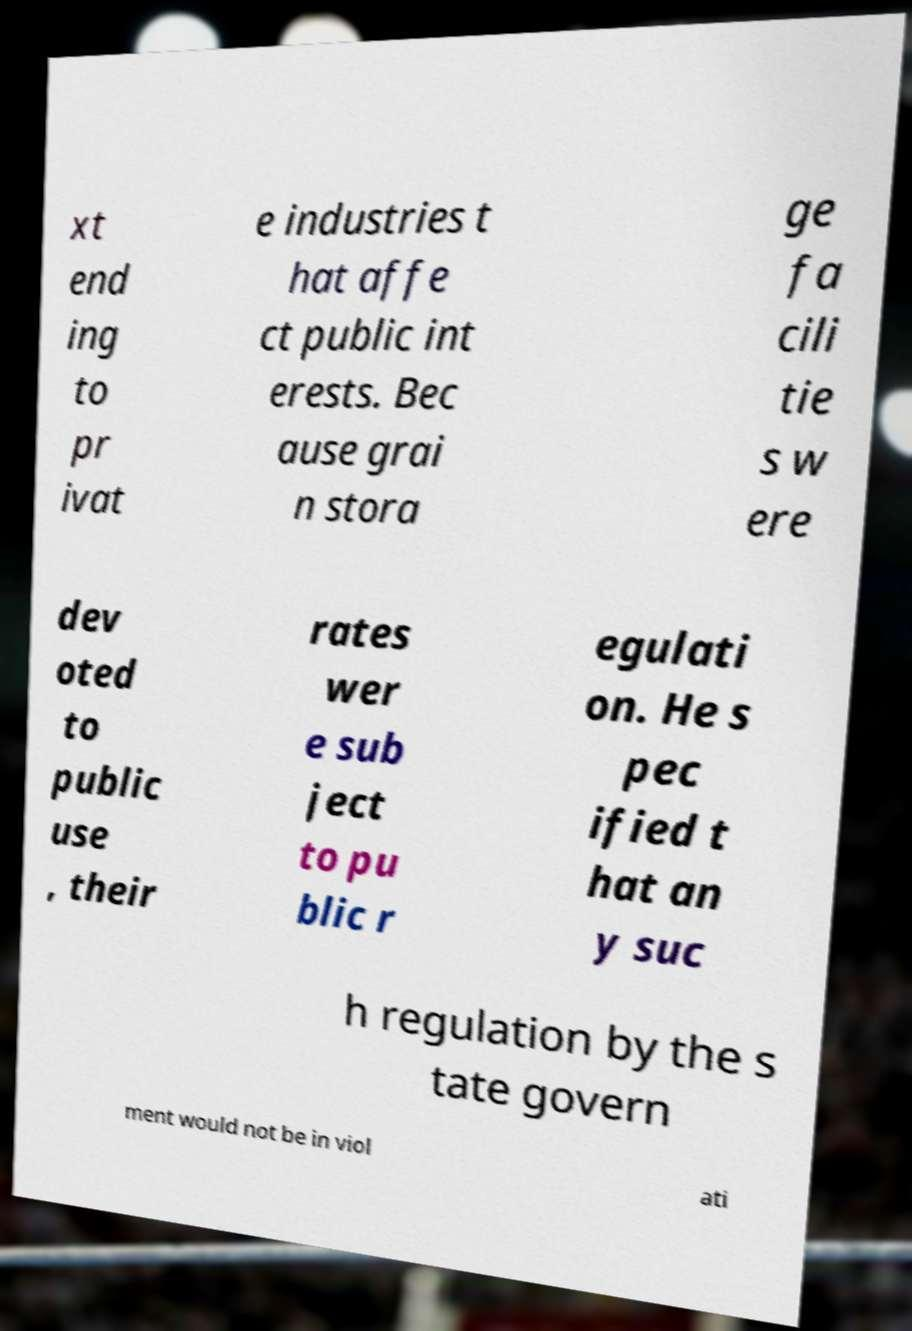I need the written content from this picture converted into text. Can you do that? xt end ing to pr ivat e industries t hat affe ct public int erests. Bec ause grai n stora ge fa cili tie s w ere dev oted to public use , their rates wer e sub ject to pu blic r egulati on. He s pec ified t hat an y suc h regulation by the s tate govern ment would not be in viol ati 